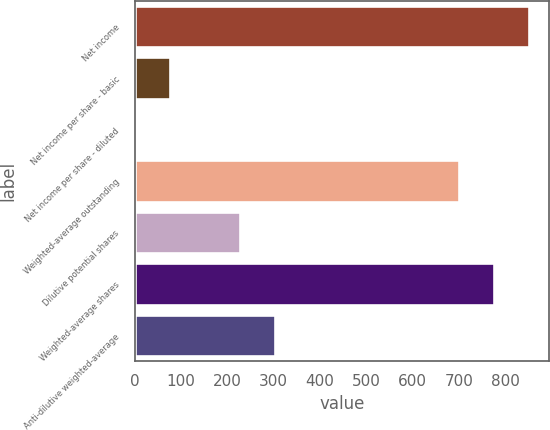Convert chart. <chart><loc_0><loc_0><loc_500><loc_500><bar_chart><fcel>Net income<fcel>Net income per share - basic<fcel>Net income per share - diluted<fcel>Weighted-average outstanding<fcel>Dilutive potential shares<fcel>Weighted-average shares<fcel>Anti-dilutive weighted-average<nl><fcel>851.78<fcel>76.45<fcel>1.06<fcel>701<fcel>227.23<fcel>776.39<fcel>302.62<nl></chart> 